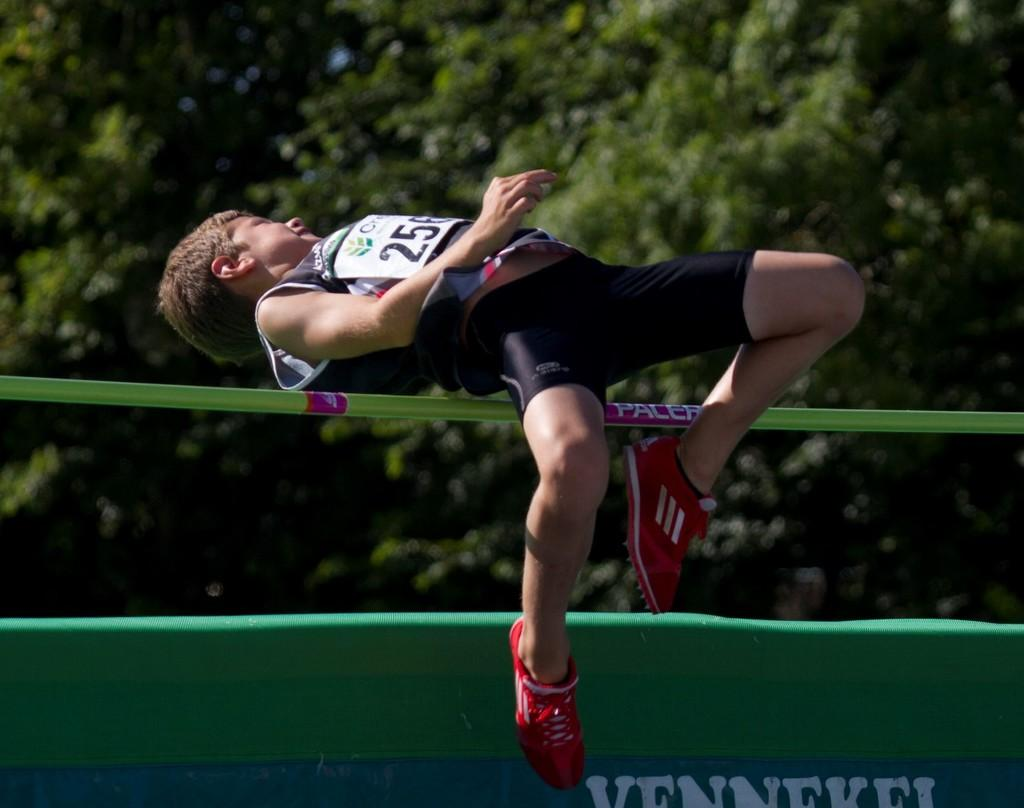<image>
Give a short and clear explanation of the subsequent image. A young boy jumping skillfully over a Pacer pole 